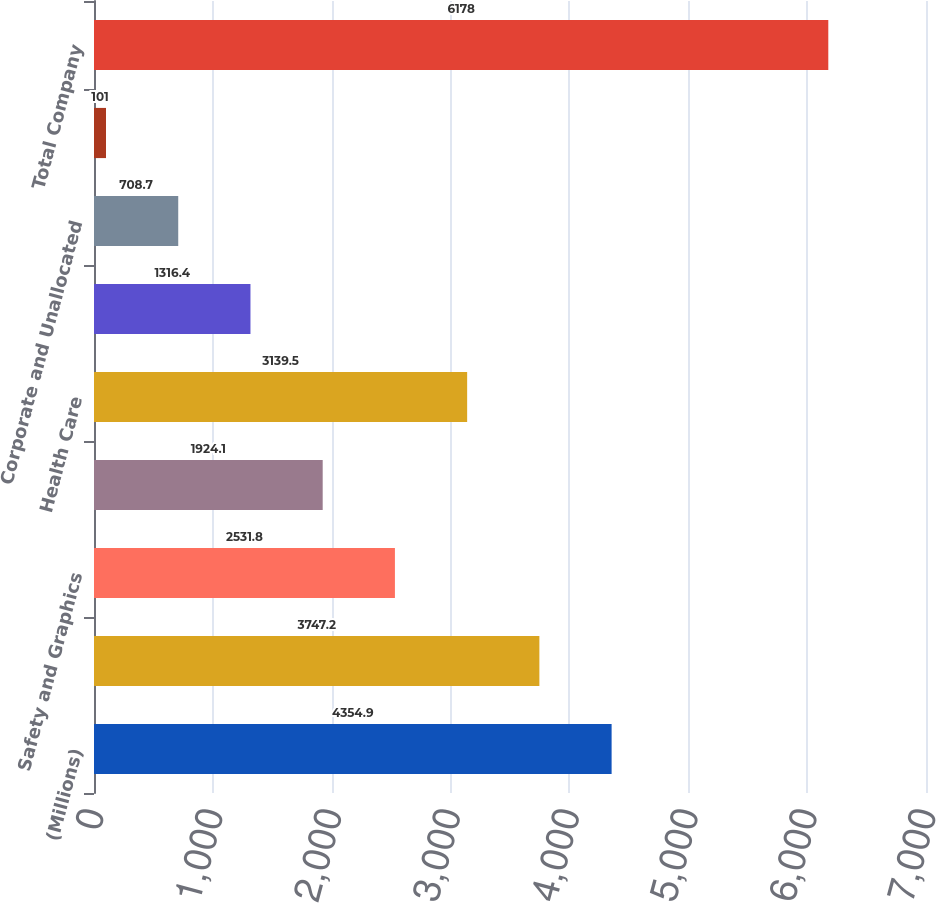Convert chart. <chart><loc_0><loc_0><loc_500><loc_500><bar_chart><fcel>(Millions)<fcel>Industrial<fcel>Safety and Graphics<fcel>Electronics and Energy<fcel>Health Care<fcel>Consumer<fcel>Corporate and Unallocated<fcel>Elimination of Dual Credit<fcel>Total Company<nl><fcel>4354.9<fcel>3747.2<fcel>2531.8<fcel>1924.1<fcel>3139.5<fcel>1316.4<fcel>708.7<fcel>101<fcel>6178<nl></chart> 